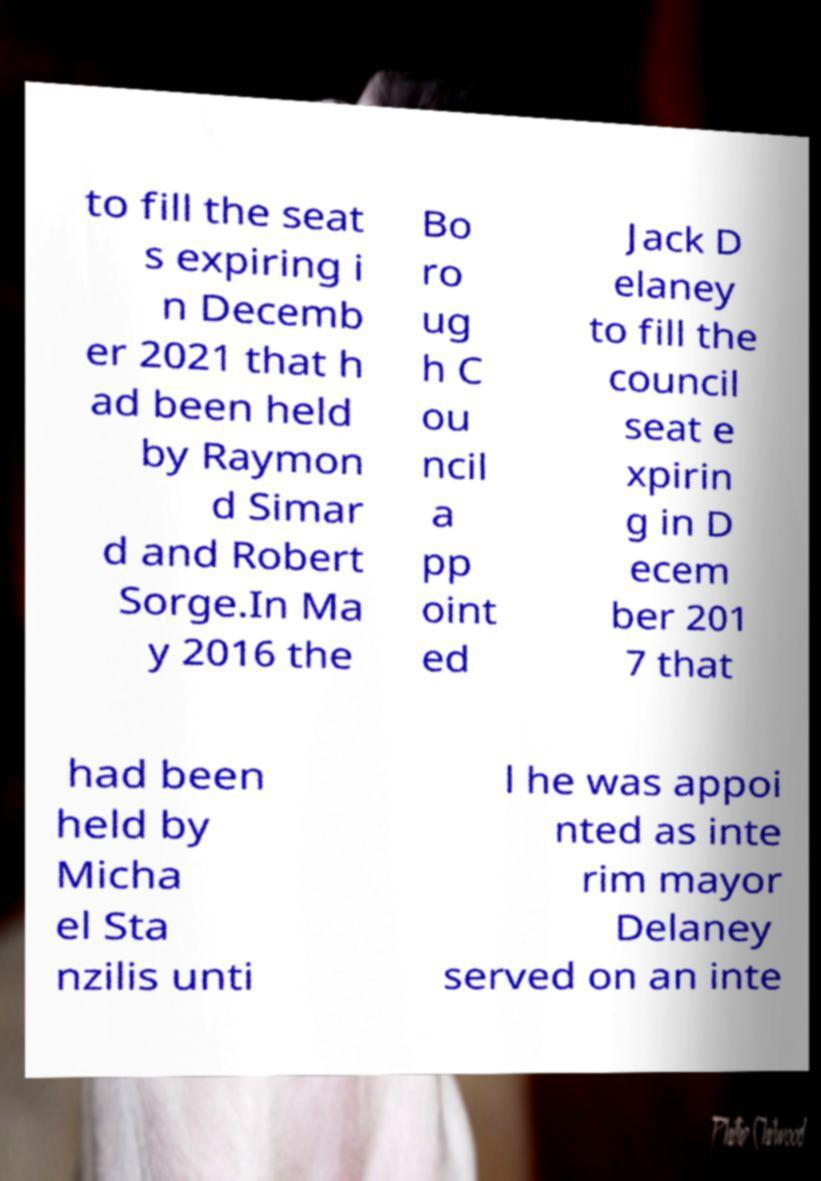What messages or text are displayed in this image? I need them in a readable, typed format. to fill the seat s expiring i n Decemb er 2021 that h ad been held by Raymon d Simar d and Robert Sorge.In Ma y 2016 the Bo ro ug h C ou ncil a pp oint ed Jack D elaney to fill the council seat e xpirin g in D ecem ber 201 7 that had been held by Micha el Sta nzilis unti l he was appoi nted as inte rim mayor Delaney served on an inte 